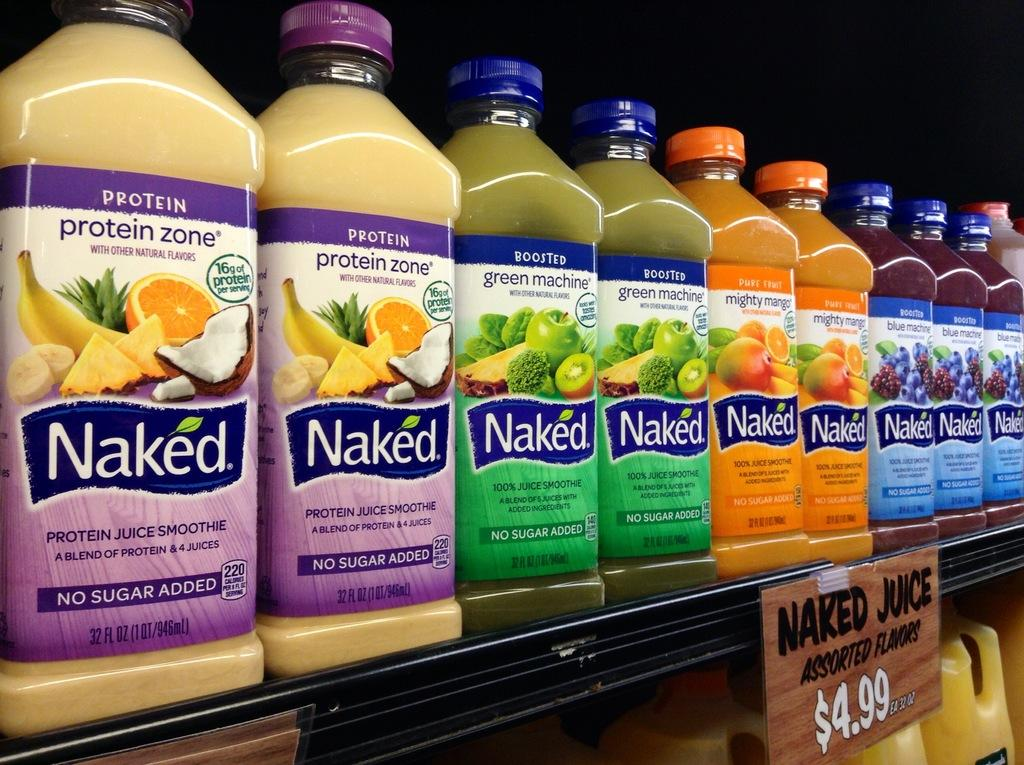What objects are on the rack in the image? There are bottles on a rack in the image. Can you describe the bottles in terms of their colors? The bottles are in multiple colors. What is the color of the board in the image? The board in the image is brown. What color is the background of the image? The background of the image is black. What type of watch is visible on the brown color board in the image? There is no watch present in the image; it features bottles on a rack, a brown color board, and a black background. 